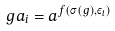Convert formula to latex. <formula><loc_0><loc_0><loc_500><loc_500>g a _ { i } = a ^ { f ( \sigma ( g ) , \varepsilon _ { i } ) }</formula> 